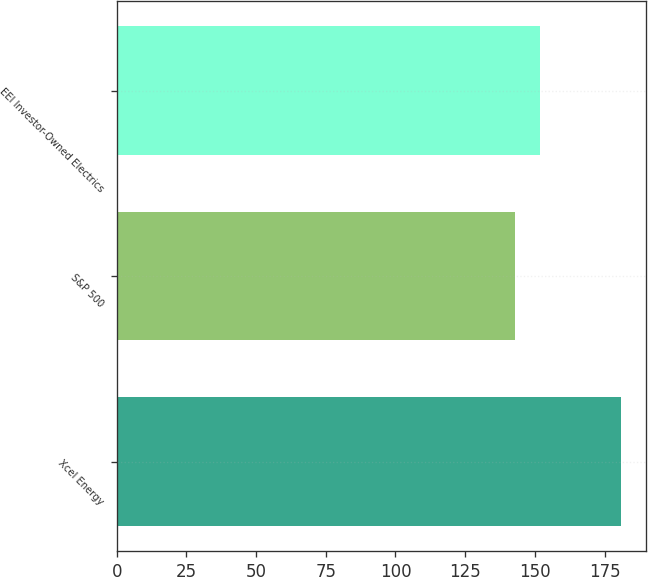Convert chart to OTSL. <chart><loc_0><loc_0><loc_500><loc_500><bar_chart><fcel>Xcel Energy<fcel>S&P 500<fcel>EEI Investor-Owned Electrics<nl><fcel>181<fcel>143<fcel>152<nl></chart> 